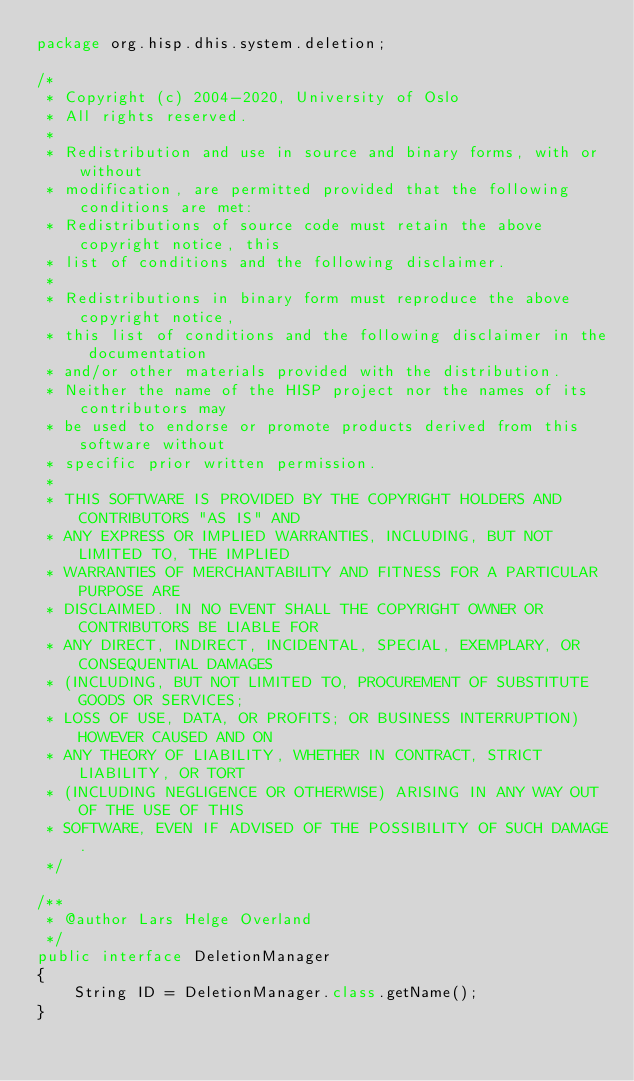Convert code to text. <code><loc_0><loc_0><loc_500><loc_500><_Java_>package org.hisp.dhis.system.deletion;

/*
 * Copyright (c) 2004-2020, University of Oslo
 * All rights reserved.
 *
 * Redistribution and use in source and binary forms, with or without
 * modification, are permitted provided that the following conditions are met:
 * Redistributions of source code must retain the above copyright notice, this
 * list of conditions and the following disclaimer.
 *
 * Redistributions in binary form must reproduce the above copyright notice,
 * this list of conditions and the following disclaimer in the documentation
 * and/or other materials provided with the distribution.
 * Neither the name of the HISP project nor the names of its contributors may
 * be used to endorse or promote products derived from this software without
 * specific prior written permission.
 *
 * THIS SOFTWARE IS PROVIDED BY THE COPYRIGHT HOLDERS AND CONTRIBUTORS "AS IS" AND
 * ANY EXPRESS OR IMPLIED WARRANTIES, INCLUDING, BUT NOT LIMITED TO, THE IMPLIED
 * WARRANTIES OF MERCHANTABILITY AND FITNESS FOR A PARTICULAR PURPOSE ARE
 * DISCLAIMED. IN NO EVENT SHALL THE COPYRIGHT OWNER OR CONTRIBUTORS BE LIABLE FOR
 * ANY DIRECT, INDIRECT, INCIDENTAL, SPECIAL, EXEMPLARY, OR CONSEQUENTIAL DAMAGES
 * (INCLUDING, BUT NOT LIMITED TO, PROCUREMENT OF SUBSTITUTE GOODS OR SERVICES;
 * LOSS OF USE, DATA, OR PROFITS; OR BUSINESS INTERRUPTION) HOWEVER CAUSED AND ON
 * ANY THEORY OF LIABILITY, WHETHER IN CONTRACT, STRICT LIABILITY, OR TORT
 * (INCLUDING NEGLIGENCE OR OTHERWISE) ARISING IN ANY WAY OUT OF THE USE OF THIS
 * SOFTWARE, EVEN IF ADVISED OF THE POSSIBILITY OF SUCH DAMAGE.
 */

/**
 * @author Lars Helge Overland
 */
public interface DeletionManager
{
    String ID = DeletionManager.class.getName();
}
</code> 